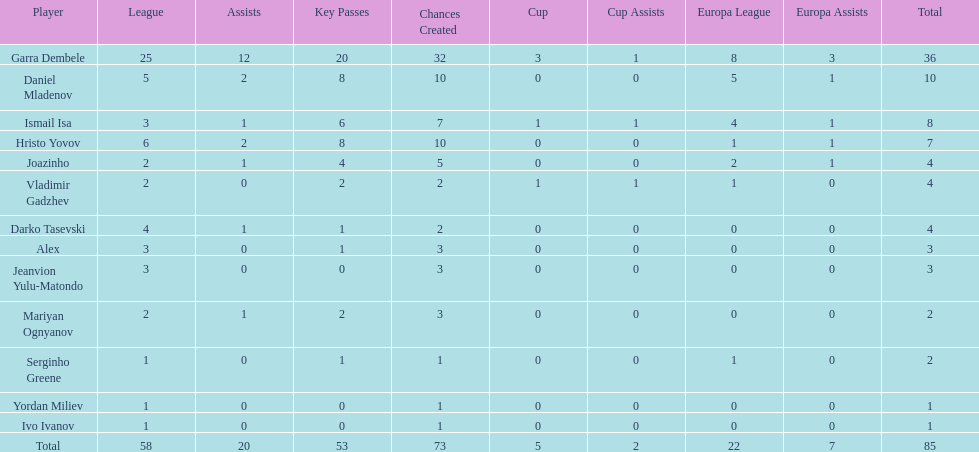How many players did not score a goal in cup play? 10. 